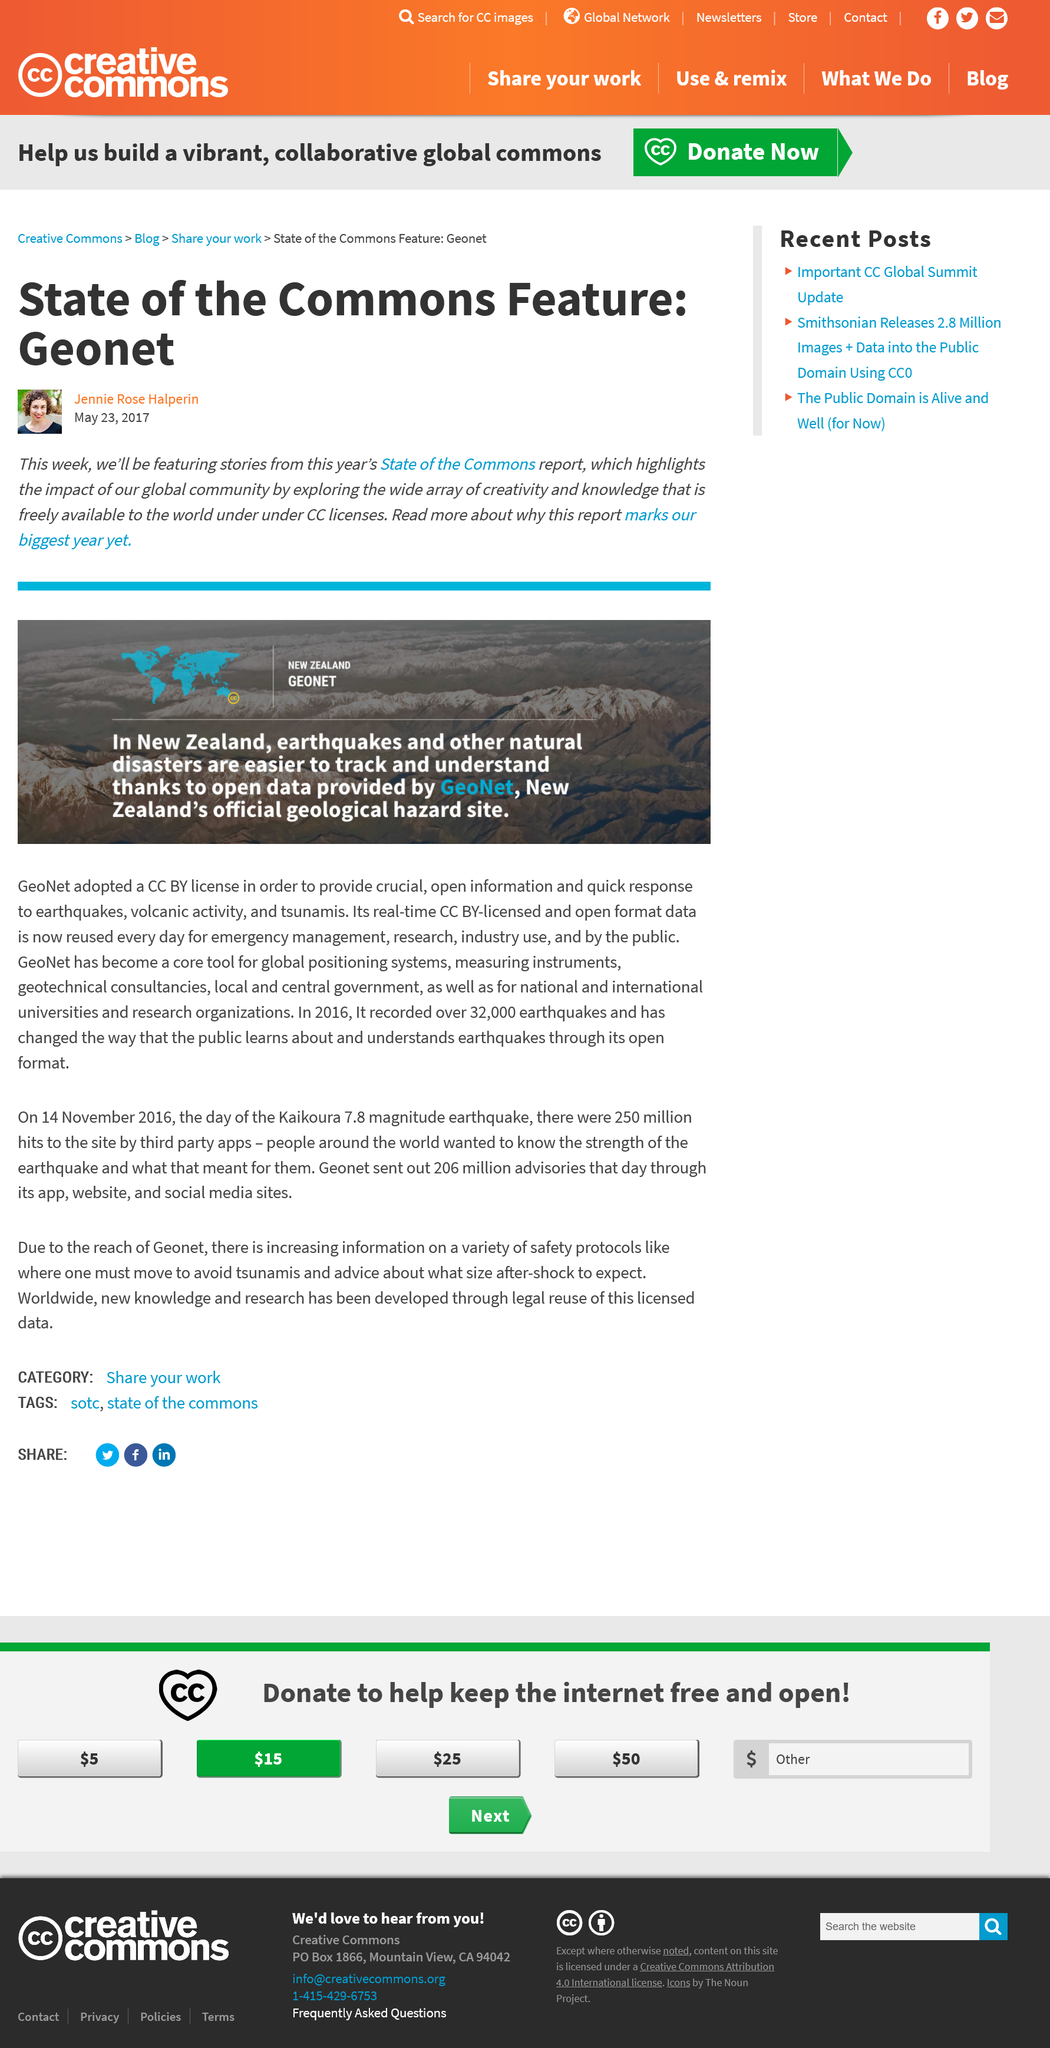Point out several critical features in this image. The New Zealand Geonet is an example of a state of the commons feature, which refers to a system or technology that provides a comprehensive view of a shared resource, such as the monitoring and tracking of a natural resource or public infrastructure. Geonet is located in New Zealand. Geonet is capable of more accurately tracking earthquakes and other natural disasters compared to other tracking methods. 